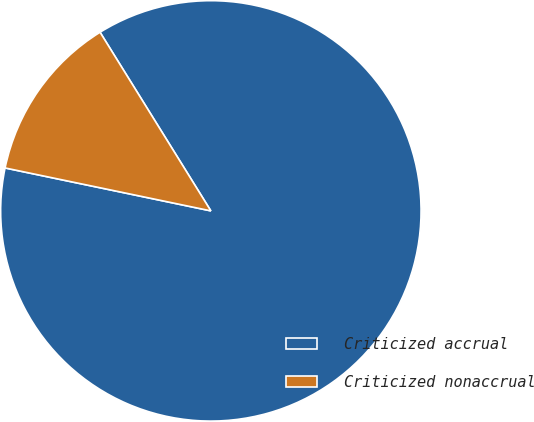<chart> <loc_0><loc_0><loc_500><loc_500><pie_chart><fcel>Criticized accrual<fcel>Criticized nonaccrual<nl><fcel>87.11%<fcel>12.89%<nl></chart> 